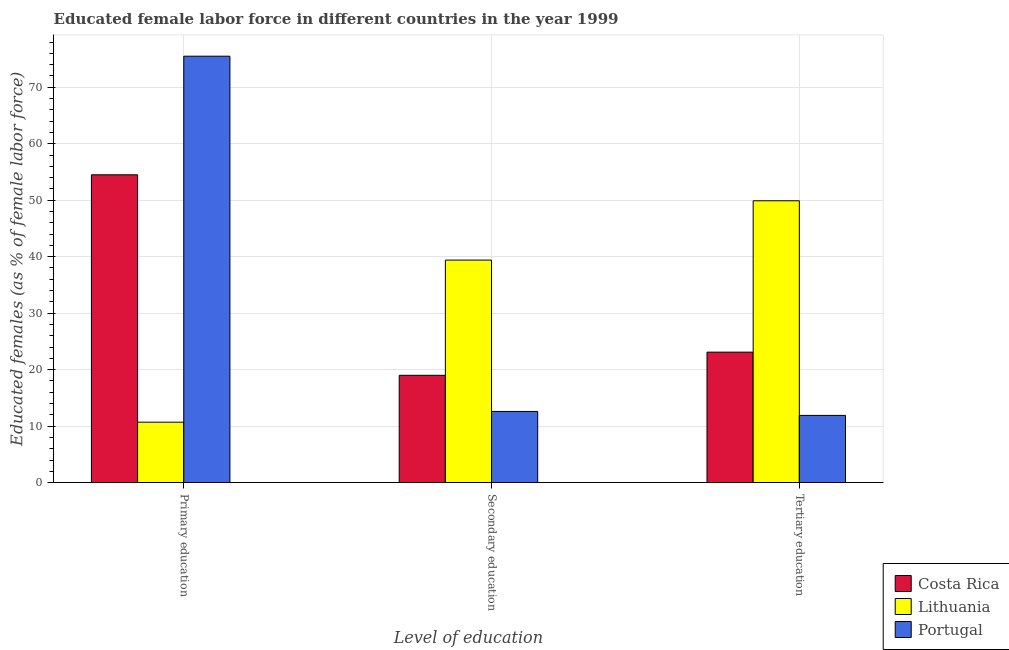How many groups of bars are there?
Offer a terse response. 3. Are the number of bars per tick equal to the number of legend labels?
Your answer should be compact. Yes. How many bars are there on the 1st tick from the right?
Your answer should be very brief. 3. What is the label of the 2nd group of bars from the left?
Provide a short and direct response. Secondary education. What is the percentage of female labor force who received tertiary education in Portugal?
Provide a short and direct response. 11.9. Across all countries, what is the maximum percentage of female labor force who received secondary education?
Ensure brevity in your answer.  39.4. Across all countries, what is the minimum percentage of female labor force who received tertiary education?
Offer a very short reply. 11.9. In which country was the percentage of female labor force who received secondary education maximum?
Keep it short and to the point. Lithuania. What is the total percentage of female labor force who received primary education in the graph?
Provide a short and direct response. 140.7. What is the difference between the percentage of female labor force who received secondary education in Lithuania and that in Costa Rica?
Your answer should be very brief. 20.4. What is the difference between the percentage of female labor force who received secondary education in Portugal and the percentage of female labor force who received tertiary education in Lithuania?
Keep it short and to the point. -37.3. What is the average percentage of female labor force who received secondary education per country?
Make the answer very short. 23.67. What is the difference between the percentage of female labor force who received secondary education and percentage of female labor force who received primary education in Portugal?
Provide a succinct answer. -62.9. What is the ratio of the percentage of female labor force who received tertiary education in Portugal to that in Costa Rica?
Offer a very short reply. 0.52. Is the percentage of female labor force who received primary education in Portugal less than that in Lithuania?
Offer a terse response. No. Is the difference between the percentage of female labor force who received tertiary education in Portugal and Lithuania greater than the difference between the percentage of female labor force who received secondary education in Portugal and Lithuania?
Offer a very short reply. No. What is the difference between the highest and the second highest percentage of female labor force who received secondary education?
Offer a very short reply. 20.4. What is the difference between the highest and the lowest percentage of female labor force who received secondary education?
Give a very brief answer. 26.8. Is the sum of the percentage of female labor force who received primary education in Portugal and Lithuania greater than the maximum percentage of female labor force who received tertiary education across all countries?
Make the answer very short. Yes. Is it the case that in every country, the sum of the percentage of female labor force who received primary education and percentage of female labor force who received secondary education is greater than the percentage of female labor force who received tertiary education?
Provide a succinct answer. Yes. How many bars are there?
Ensure brevity in your answer.  9. Are all the bars in the graph horizontal?
Your answer should be compact. No. Does the graph contain any zero values?
Offer a terse response. No. Where does the legend appear in the graph?
Ensure brevity in your answer.  Bottom right. How are the legend labels stacked?
Provide a succinct answer. Vertical. What is the title of the graph?
Provide a succinct answer. Educated female labor force in different countries in the year 1999. What is the label or title of the X-axis?
Your answer should be very brief. Level of education. What is the label or title of the Y-axis?
Your response must be concise. Educated females (as % of female labor force). What is the Educated females (as % of female labor force) of Costa Rica in Primary education?
Make the answer very short. 54.5. What is the Educated females (as % of female labor force) of Lithuania in Primary education?
Provide a succinct answer. 10.7. What is the Educated females (as % of female labor force) in Portugal in Primary education?
Your answer should be very brief. 75.5. What is the Educated females (as % of female labor force) of Costa Rica in Secondary education?
Make the answer very short. 19. What is the Educated females (as % of female labor force) of Lithuania in Secondary education?
Your answer should be compact. 39.4. What is the Educated females (as % of female labor force) in Portugal in Secondary education?
Your response must be concise. 12.6. What is the Educated females (as % of female labor force) of Costa Rica in Tertiary education?
Give a very brief answer. 23.1. What is the Educated females (as % of female labor force) in Lithuania in Tertiary education?
Keep it short and to the point. 49.9. What is the Educated females (as % of female labor force) of Portugal in Tertiary education?
Provide a succinct answer. 11.9. Across all Level of education, what is the maximum Educated females (as % of female labor force) of Costa Rica?
Your answer should be very brief. 54.5. Across all Level of education, what is the maximum Educated females (as % of female labor force) of Lithuania?
Ensure brevity in your answer.  49.9. Across all Level of education, what is the maximum Educated females (as % of female labor force) in Portugal?
Provide a short and direct response. 75.5. Across all Level of education, what is the minimum Educated females (as % of female labor force) of Lithuania?
Offer a very short reply. 10.7. Across all Level of education, what is the minimum Educated females (as % of female labor force) of Portugal?
Your answer should be very brief. 11.9. What is the total Educated females (as % of female labor force) in Costa Rica in the graph?
Offer a terse response. 96.6. What is the total Educated females (as % of female labor force) of Lithuania in the graph?
Provide a short and direct response. 100. What is the total Educated females (as % of female labor force) of Portugal in the graph?
Give a very brief answer. 100. What is the difference between the Educated females (as % of female labor force) in Costa Rica in Primary education and that in Secondary education?
Keep it short and to the point. 35.5. What is the difference between the Educated females (as % of female labor force) in Lithuania in Primary education and that in Secondary education?
Provide a short and direct response. -28.7. What is the difference between the Educated females (as % of female labor force) of Portugal in Primary education and that in Secondary education?
Ensure brevity in your answer.  62.9. What is the difference between the Educated females (as % of female labor force) of Costa Rica in Primary education and that in Tertiary education?
Offer a terse response. 31.4. What is the difference between the Educated females (as % of female labor force) of Lithuania in Primary education and that in Tertiary education?
Your answer should be compact. -39.2. What is the difference between the Educated females (as % of female labor force) of Portugal in Primary education and that in Tertiary education?
Keep it short and to the point. 63.6. What is the difference between the Educated females (as % of female labor force) of Costa Rica in Secondary education and that in Tertiary education?
Keep it short and to the point. -4.1. What is the difference between the Educated females (as % of female labor force) in Lithuania in Secondary education and that in Tertiary education?
Your answer should be compact. -10.5. What is the difference between the Educated females (as % of female labor force) of Portugal in Secondary education and that in Tertiary education?
Your answer should be very brief. 0.7. What is the difference between the Educated females (as % of female labor force) in Costa Rica in Primary education and the Educated females (as % of female labor force) in Portugal in Secondary education?
Offer a terse response. 41.9. What is the difference between the Educated females (as % of female labor force) of Costa Rica in Primary education and the Educated females (as % of female labor force) of Portugal in Tertiary education?
Make the answer very short. 42.6. What is the difference between the Educated females (as % of female labor force) of Costa Rica in Secondary education and the Educated females (as % of female labor force) of Lithuania in Tertiary education?
Give a very brief answer. -30.9. What is the average Educated females (as % of female labor force) in Costa Rica per Level of education?
Keep it short and to the point. 32.2. What is the average Educated females (as % of female labor force) in Lithuania per Level of education?
Make the answer very short. 33.33. What is the average Educated females (as % of female labor force) of Portugal per Level of education?
Provide a succinct answer. 33.33. What is the difference between the Educated females (as % of female labor force) of Costa Rica and Educated females (as % of female labor force) of Lithuania in Primary education?
Your answer should be compact. 43.8. What is the difference between the Educated females (as % of female labor force) in Lithuania and Educated females (as % of female labor force) in Portugal in Primary education?
Offer a very short reply. -64.8. What is the difference between the Educated females (as % of female labor force) in Costa Rica and Educated females (as % of female labor force) in Lithuania in Secondary education?
Ensure brevity in your answer.  -20.4. What is the difference between the Educated females (as % of female labor force) of Lithuania and Educated females (as % of female labor force) of Portugal in Secondary education?
Provide a succinct answer. 26.8. What is the difference between the Educated females (as % of female labor force) of Costa Rica and Educated females (as % of female labor force) of Lithuania in Tertiary education?
Make the answer very short. -26.8. What is the difference between the Educated females (as % of female labor force) in Lithuania and Educated females (as % of female labor force) in Portugal in Tertiary education?
Offer a very short reply. 38. What is the ratio of the Educated females (as % of female labor force) in Costa Rica in Primary education to that in Secondary education?
Ensure brevity in your answer.  2.87. What is the ratio of the Educated females (as % of female labor force) in Lithuania in Primary education to that in Secondary education?
Offer a terse response. 0.27. What is the ratio of the Educated females (as % of female labor force) in Portugal in Primary education to that in Secondary education?
Offer a terse response. 5.99. What is the ratio of the Educated females (as % of female labor force) in Costa Rica in Primary education to that in Tertiary education?
Your response must be concise. 2.36. What is the ratio of the Educated females (as % of female labor force) of Lithuania in Primary education to that in Tertiary education?
Ensure brevity in your answer.  0.21. What is the ratio of the Educated females (as % of female labor force) of Portugal in Primary education to that in Tertiary education?
Give a very brief answer. 6.34. What is the ratio of the Educated females (as % of female labor force) of Costa Rica in Secondary education to that in Tertiary education?
Offer a very short reply. 0.82. What is the ratio of the Educated females (as % of female labor force) in Lithuania in Secondary education to that in Tertiary education?
Keep it short and to the point. 0.79. What is the ratio of the Educated females (as % of female labor force) in Portugal in Secondary education to that in Tertiary education?
Provide a succinct answer. 1.06. What is the difference between the highest and the second highest Educated females (as % of female labor force) of Costa Rica?
Provide a succinct answer. 31.4. What is the difference between the highest and the second highest Educated females (as % of female labor force) of Lithuania?
Provide a short and direct response. 10.5. What is the difference between the highest and the second highest Educated females (as % of female labor force) of Portugal?
Keep it short and to the point. 62.9. What is the difference between the highest and the lowest Educated females (as % of female labor force) in Costa Rica?
Keep it short and to the point. 35.5. What is the difference between the highest and the lowest Educated females (as % of female labor force) in Lithuania?
Offer a very short reply. 39.2. What is the difference between the highest and the lowest Educated females (as % of female labor force) in Portugal?
Give a very brief answer. 63.6. 